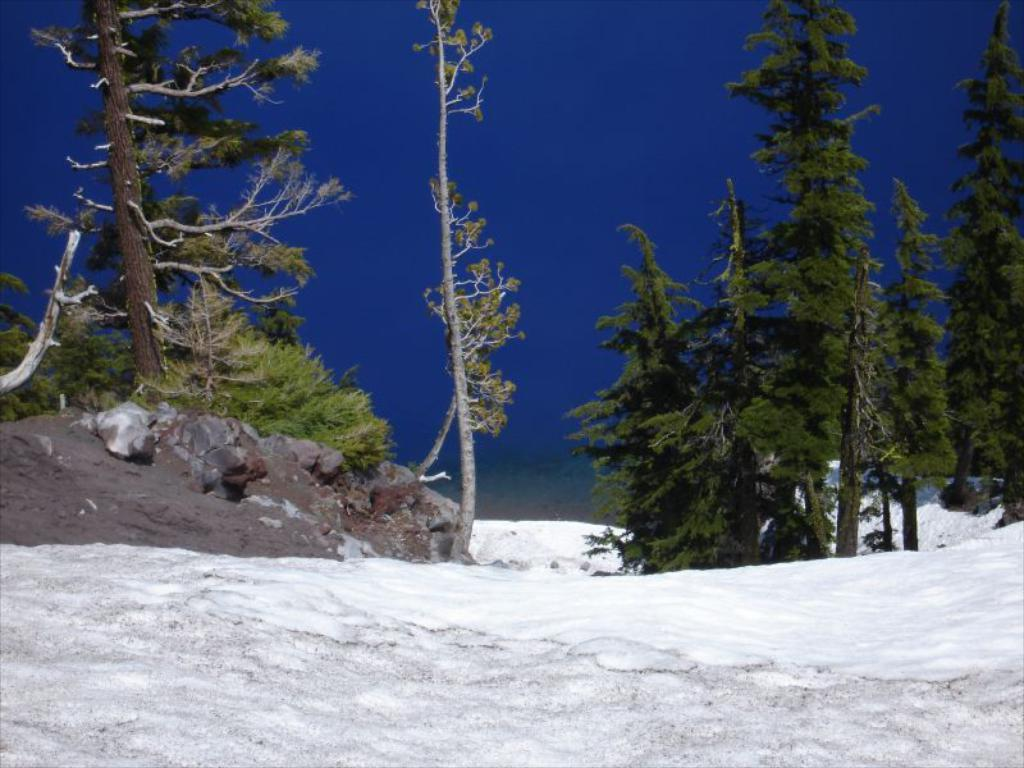What type of weather condition is depicted in the image? There is snow in the image, indicating a winter scene. What natural elements can be seen in the background of the image? There are trees at the back of the image. What is visible at the top of the image? The sky is visible at the top of the image. What type of oatmeal is being used to paint the trees in the image? There is no oatmeal or painting activity present in the image; it depicts a snowy scene with trees in the background. 